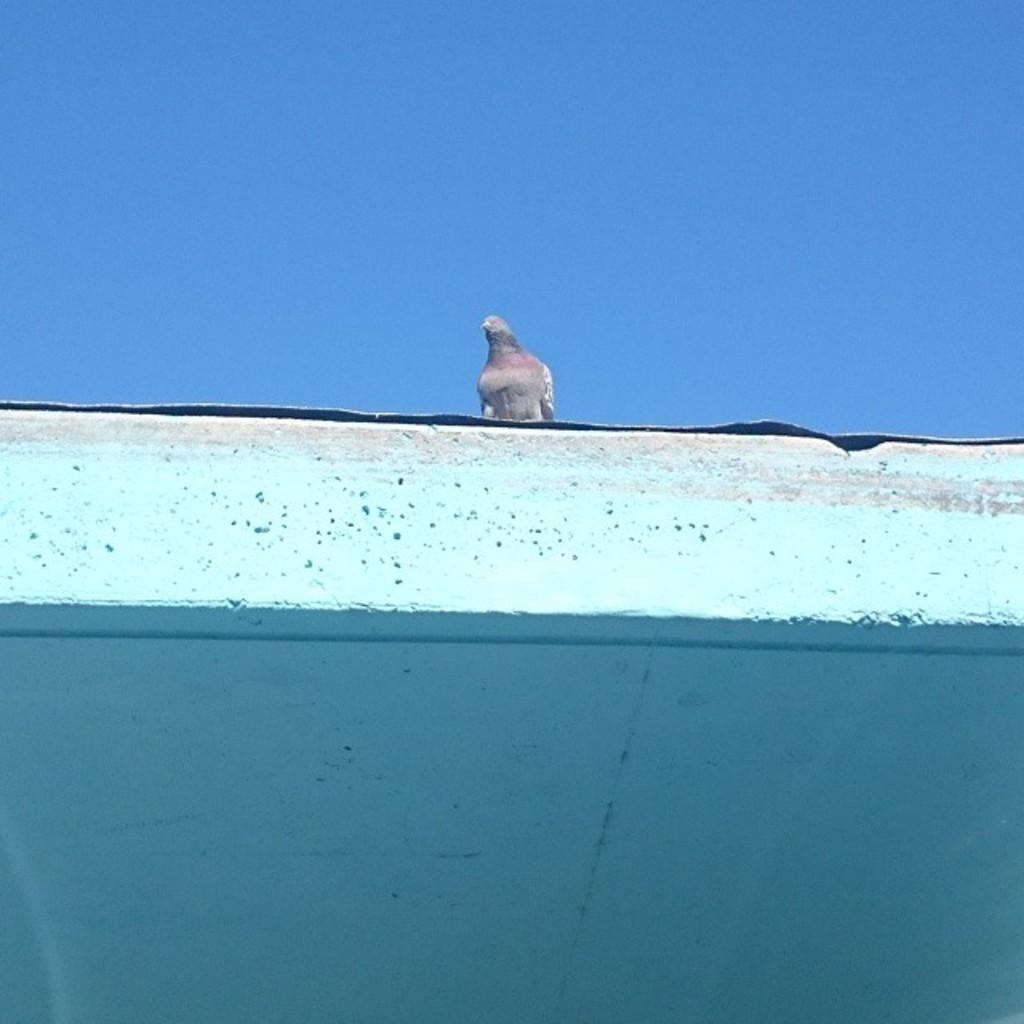What type of bird is in the image? There is a pigeon in the image. Where is the pigeon located? The pigeon is sitting on a white concrete roof. What can be seen in the background of the image? The sky is visible in the image. How many lines are visible on the pigeon's wings in the image? There are no lines visible on the pigeon's wings in the image. What type of shade is provided by the white concrete roof in the image? The white concrete roof does not provide any shade in the image, as it is a flat surface. 